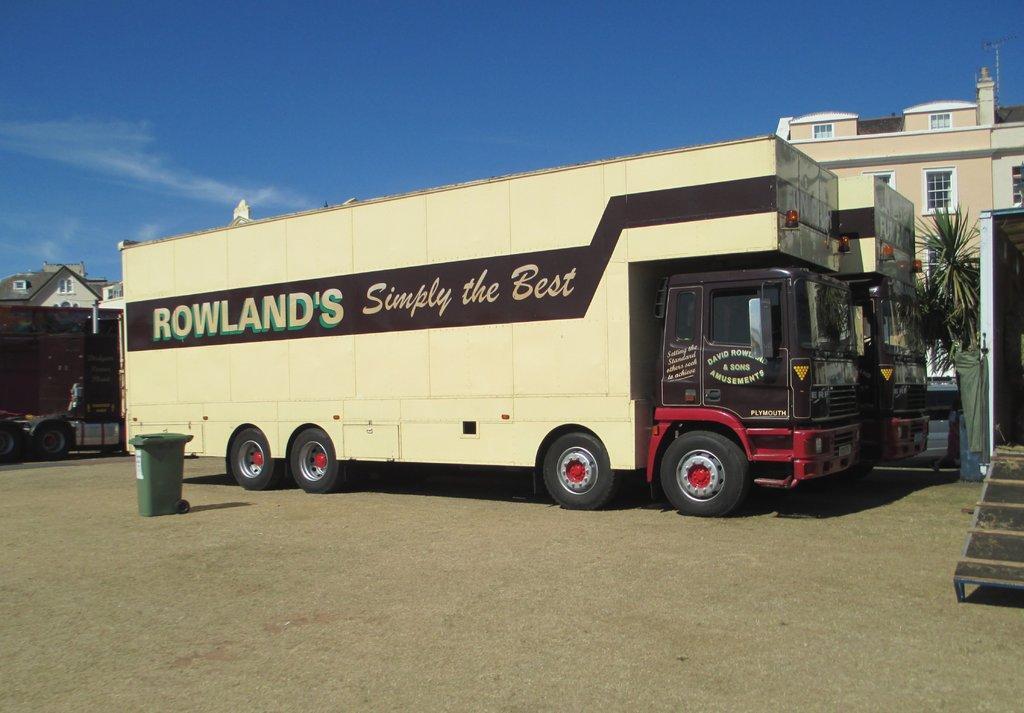Please provide a concise description of this image. In this image there are two trucks on the ground. In the background there is a building. At the top there is sky. On the left side there is another truck on the ground. Beside the truck there is a green colour dustbin. On the right side there is a truck with the open door. 